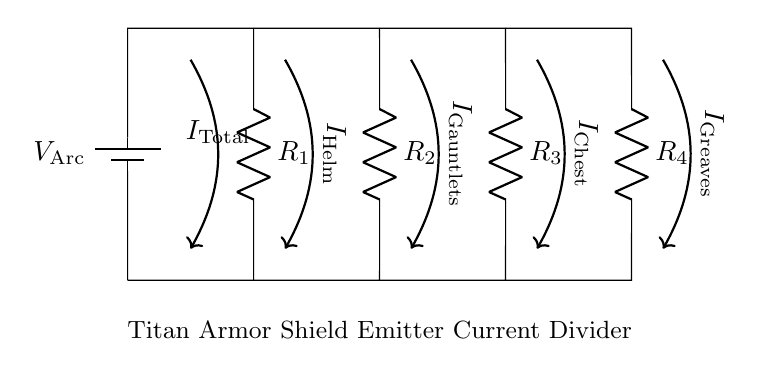What is the total current entering the circuit? The total current, denoted as I_total, is indicated by the arrow labeled I_total in the diagram. This represents the current supplied by the voltage source to the entire circuit.
Answer: I_total How many resistors are present in this circuit? The circuit diagram shows four resistors labeled as R_1, R_2, R_3, and R_4. By counting these components, we determine the total number of resistors in the circuit.
Answer: Four What is the role of the current divider in this circuit? The current divider is used to split the total current I_total into multiple branches, providing distinct current values (I_Helm, I_Gauntlets, I_Chest, I_Greaves) for each path connected to the respective resistors.
Answer: Split current What current flows through the Helm according to the diagram? The current flowing through the Helm is indicated as I_Helm, which is shown along the path from the main circuit to the Helm's resistor, labeled as R_2. Therefore, I_Helm is the current associated with that specific branch.
Answer: I_Helm If R_1 has a value of 10 ohms and the current I_total is 20 amps, what is the current through R_1? To find the current through R_1, you apply the current division principle. Since R_1 is one of the branches in this circuit, the current is divided according to the resistor values. Without specific values for R_2, R_3, and R_4, a direct calculation cannot be performed. However, I_1 can be expressed through the total current relation when the resistances are known.
Answer: Calculation needed Which branch has the highest current output? The branch with the lowest resistance will have the highest current according to Ohm’s Law. The question requires evaluating the resistor values, but all selected resistors need to be observed from the current divider perspective without their specific values to determine which output has the maximum current.
Answer: Depend on R values What is the function of the battery labeled V_Arc? The battery labeled V_Arc provides the necessary voltage supply for the circuit, establishing the potential difference that drives the current through the resistors and thereby enabling the operation of the Titan armor shield emitters.
Answer: Power supply 